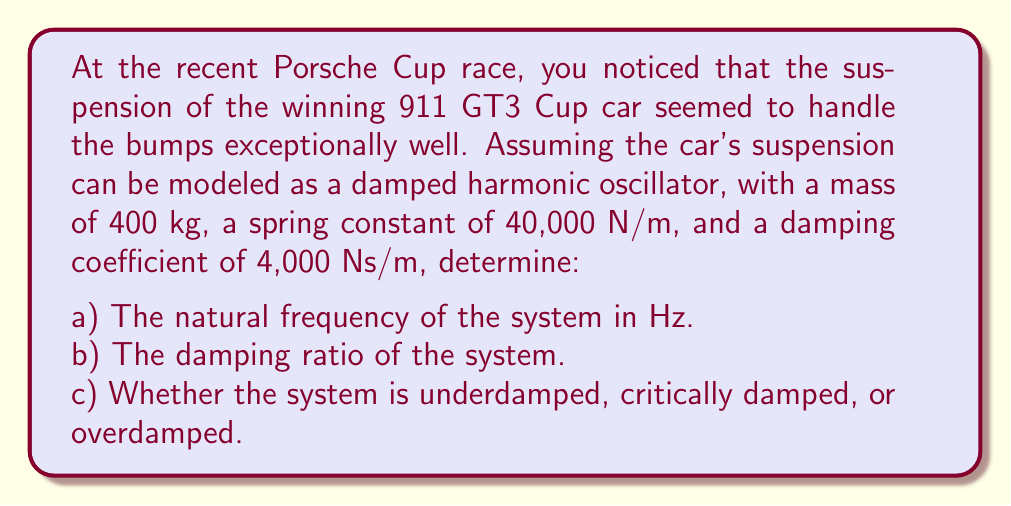Can you answer this question? Let's approach this problem step by step using the damped harmonic oscillator equation:

$$m\frac{d^2x}{dt^2} + c\frac{dx}{dt} + kx = 0$$

Where:
$m$ = mass (400 kg)
$c$ = damping coefficient (4,000 Ns/m)
$k$ = spring constant (40,000 N/m)

a) To find the natural frequency:

The natural angular frequency $\omega_n$ is given by:

$$\omega_n = \sqrt{\frac{k}{m}}$$

Substituting the values:

$$\omega_n = \sqrt{\frac{40,000}{400}} = 10 \text{ rad/s}$$

To convert to Hz, we divide by $2\pi$:

$$f_n = \frac{\omega_n}{2\pi} = \frac{10}{2\pi} \approx 1.59 \text{ Hz}$$

b) The damping ratio $\zeta$ is given by:

$$\zeta = \frac{c}{2\sqrt{km}}$$

Substituting the values:

$$\zeta = \frac{4,000}{2\sqrt{40,000 \cdot 400}} = \frac{4,000}{2\sqrt{16,000,000}} = \frac{4,000}{8,000} = 0.5$$

c) To determine whether the system is underdamped, critically damped, or overdamped, we compare the damping ratio to 1:

- If $\zeta < 1$, the system is underdamped
- If $\zeta = 1$, the system is critically damped
- If $\zeta > 1$, the system is overdamped

Since $\zeta = 0.5 < 1$, the system is underdamped.
Answer: a) Natural frequency: 1.59 Hz
b) Damping ratio: 0.5
c) The system is underdamped 